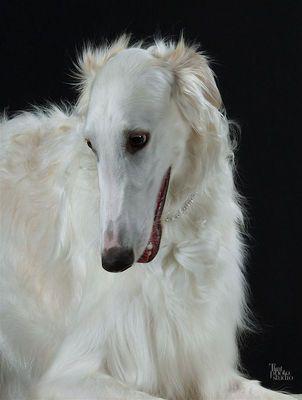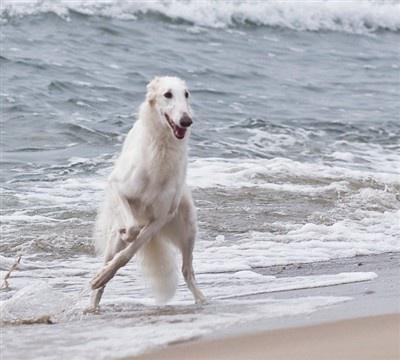The first image is the image on the left, the second image is the image on the right. Considering the images on both sides, is "One of the dogs is in the snow." valid? Answer yes or no. No. The first image is the image on the left, the second image is the image on the right. For the images shown, is this caption "Each image contains one silky haired white afghan hound, and one dog has his head lowered to the left." true? Answer yes or no. Yes. 